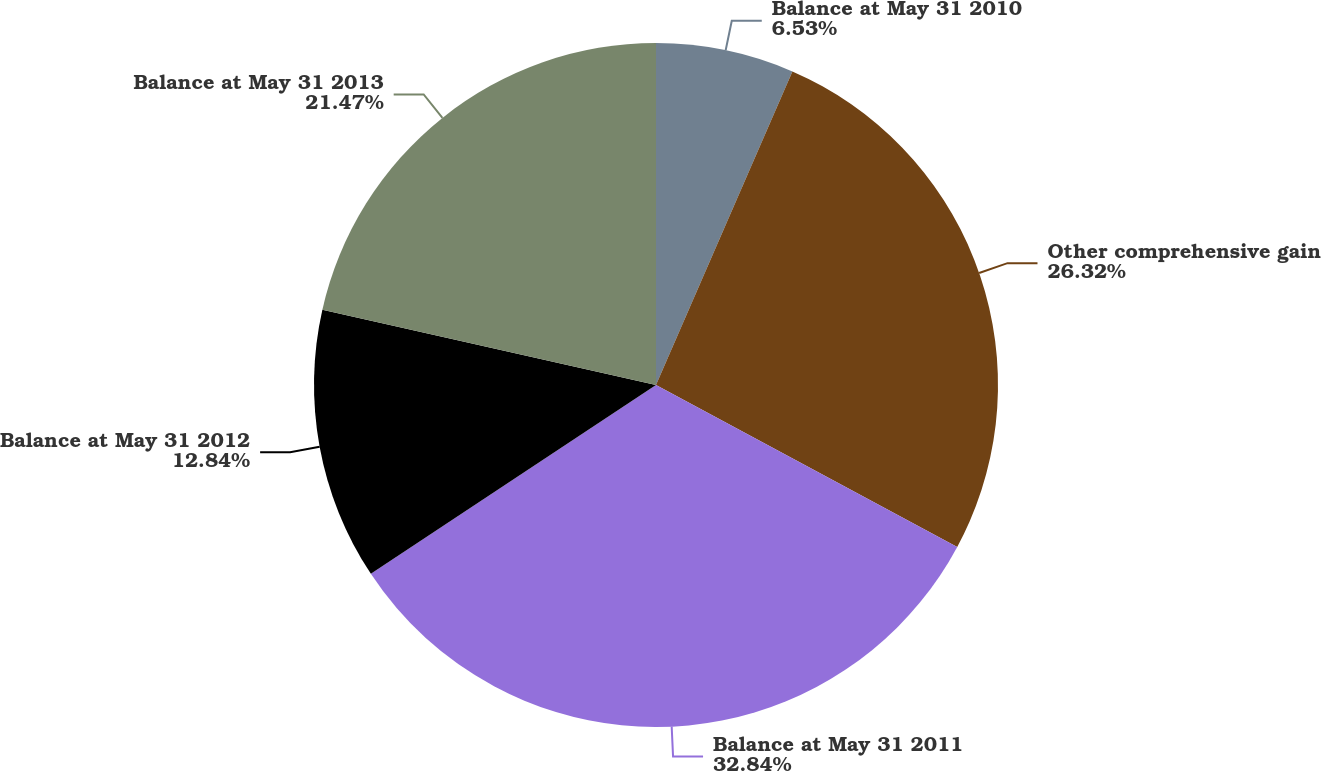Convert chart. <chart><loc_0><loc_0><loc_500><loc_500><pie_chart><fcel>Balance at May 31 2010<fcel>Other comprehensive gain<fcel>Balance at May 31 2011<fcel>Balance at May 31 2012<fcel>Balance at May 31 2013<nl><fcel>6.53%<fcel>26.32%<fcel>32.84%<fcel>12.84%<fcel>21.47%<nl></chart> 